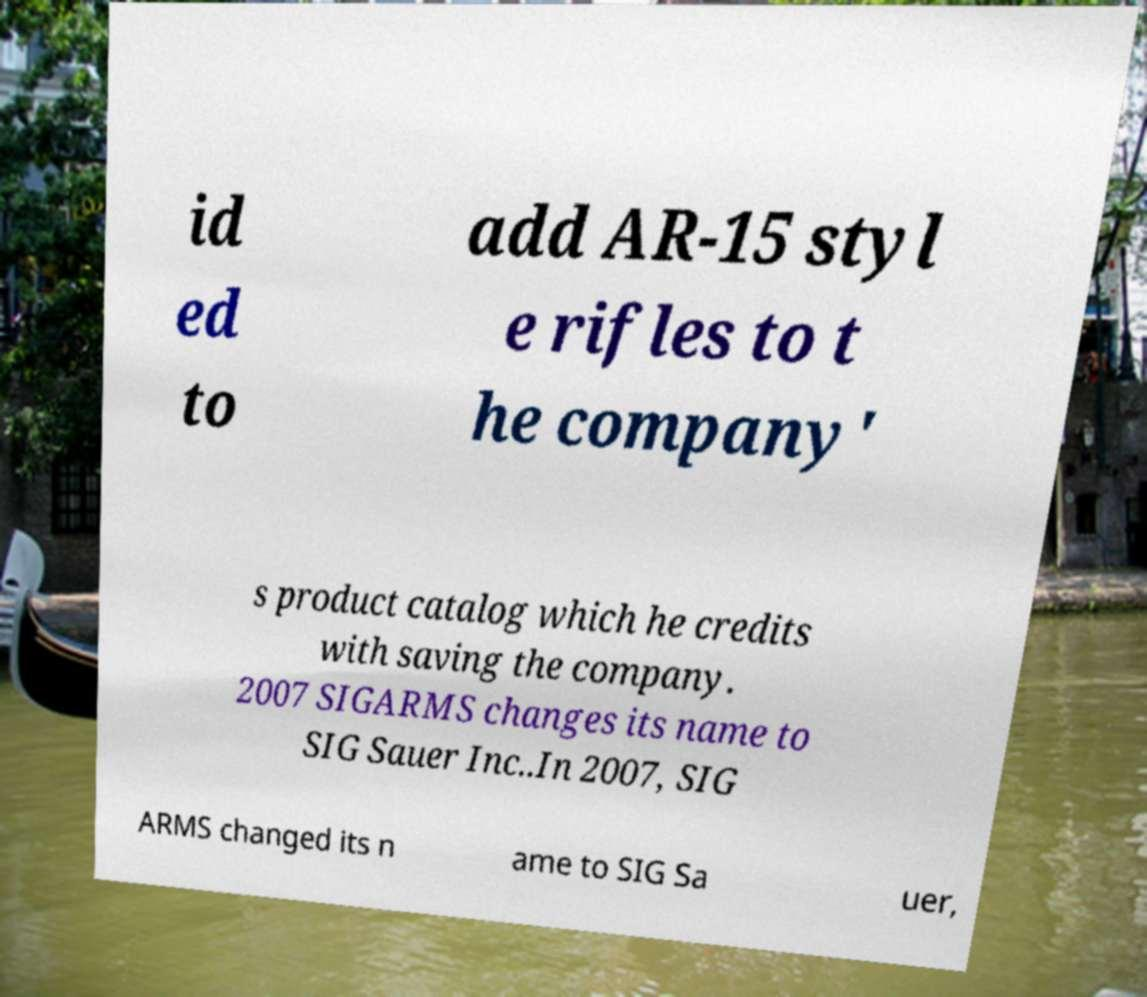Can you accurately transcribe the text from the provided image for me? id ed to add AR-15 styl e rifles to t he company' s product catalog which he credits with saving the company. 2007 SIGARMS changes its name to SIG Sauer Inc..In 2007, SIG ARMS changed its n ame to SIG Sa uer, 